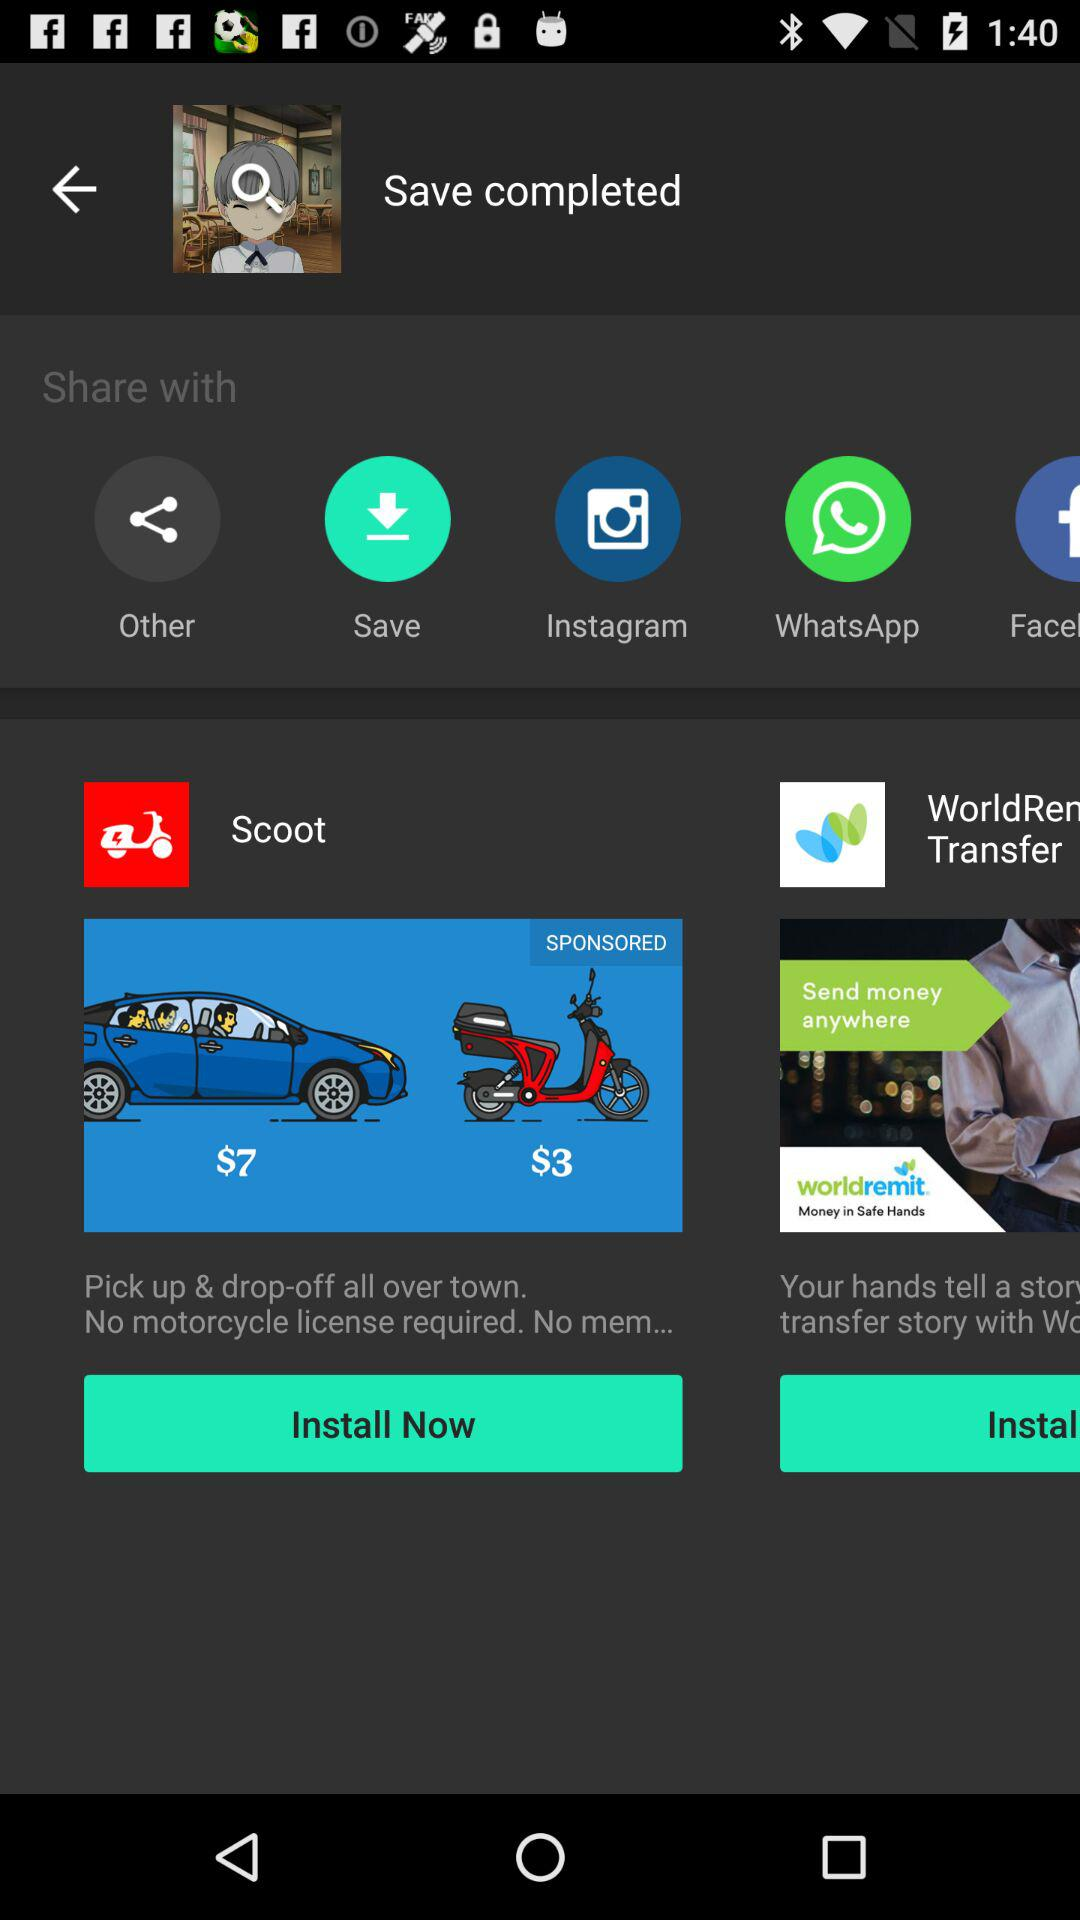What applications can be used to share? The applications that can be used to share are "Instagram" and "WhatsApp". 